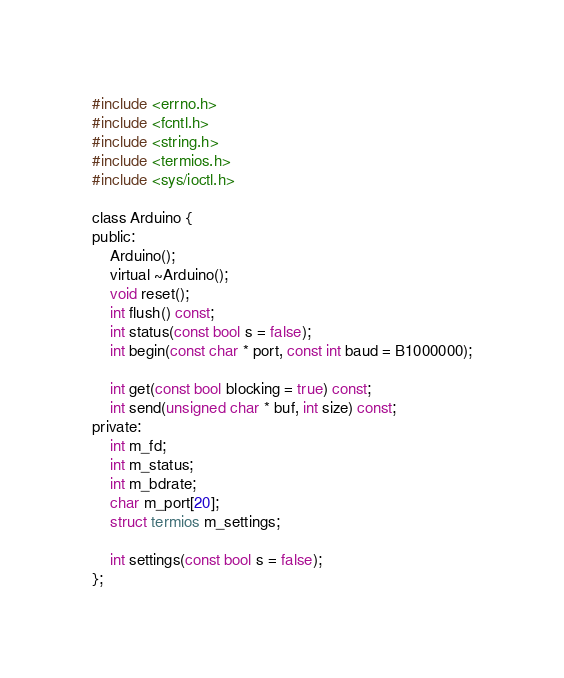<code> <loc_0><loc_0><loc_500><loc_500><_C_>#include <errno.h>
#include <fcntl.h>
#include <string.h>
#include <termios.h>
#include <sys/ioctl.h>

class Arduino {
public:
	Arduino();
	virtual ~Arduino();
	void reset();
	int flush() const;
	int status(const bool s = false);
	int begin(const char * port, const int baud = B1000000);

	int get(const bool blocking = true) const;
	int send(unsigned char * buf, int size) const;
private:
	int m_fd;
	int m_status;
	int m_bdrate;
	char m_port[20];
	struct termios m_settings;

	int settings(const bool s = false);
};
</code> 